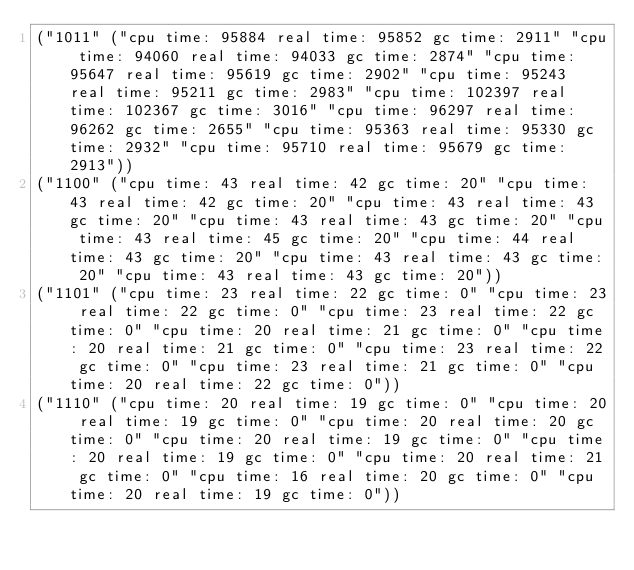Convert code to text. <code><loc_0><loc_0><loc_500><loc_500><_Racket_>("1011" ("cpu time: 95884 real time: 95852 gc time: 2911" "cpu time: 94060 real time: 94033 gc time: 2874" "cpu time: 95647 real time: 95619 gc time: 2902" "cpu time: 95243 real time: 95211 gc time: 2983" "cpu time: 102397 real time: 102367 gc time: 3016" "cpu time: 96297 real time: 96262 gc time: 2655" "cpu time: 95363 real time: 95330 gc time: 2932" "cpu time: 95710 real time: 95679 gc time: 2913"))
("1100" ("cpu time: 43 real time: 42 gc time: 20" "cpu time: 43 real time: 42 gc time: 20" "cpu time: 43 real time: 43 gc time: 20" "cpu time: 43 real time: 43 gc time: 20" "cpu time: 43 real time: 45 gc time: 20" "cpu time: 44 real time: 43 gc time: 20" "cpu time: 43 real time: 43 gc time: 20" "cpu time: 43 real time: 43 gc time: 20"))
("1101" ("cpu time: 23 real time: 22 gc time: 0" "cpu time: 23 real time: 22 gc time: 0" "cpu time: 23 real time: 22 gc time: 0" "cpu time: 20 real time: 21 gc time: 0" "cpu time: 20 real time: 21 gc time: 0" "cpu time: 23 real time: 22 gc time: 0" "cpu time: 23 real time: 21 gc time: 0" "cpu time: 20 real time: 22 gc time: 0"))
("1110" ("cpu time: 20 real time: 19 gc time: 0" "cpu time: 20 real time: 19 gc time: 0" "cpu time: 20 real time: 20 gc time: 0" "cpu time: 20 real time: 19 gc time: 0" "cpu time: 20 real time: 19 gc time: 0" "cpu time: 20 real time: 21 gc time: 0" "cpu time: 16 real time: 20 gc time: 0" "cpu time: 20 real time: 19 gc time: 0"))</code> 